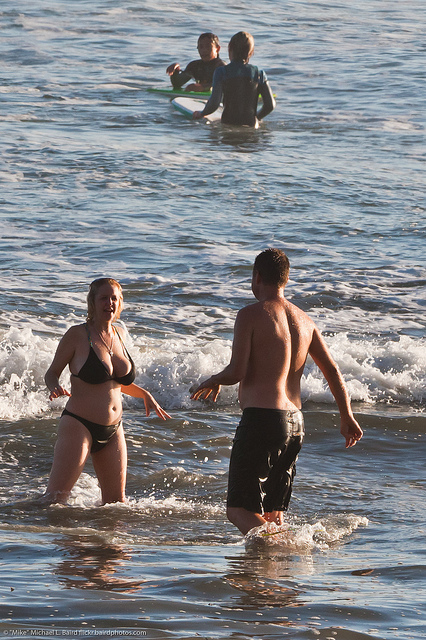Describe the environment depicted in this image. The image captures a serene beach scene with the ocean gently lapping at the shore. The sun is casting a warm glow, suggesting it's either early morning or late afternoon, judging by the lengthened shadows and soft light. People are engaged in leisure activities, enjoying the calm waters close to the shoreline. 